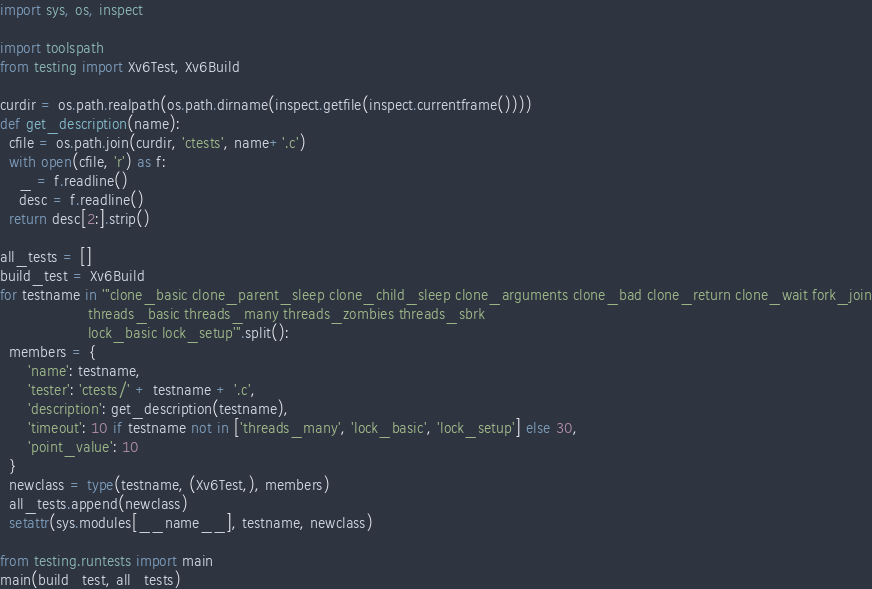Convert code to text. <code><loc_0><loc_0><loc_500><loc_500><_Python_>import sys, os, inspect

import toolspath
from testing import Xv6Test, Xv6Build

curdir = os.path.realpath(os.path.dirname(inspect.getfile(inspect.currentframe())))
def get_description(name):
  cfile = os.path.join(curdir, 'ctests', name+'.c')
  with open(cfile, 'r') as f:
    _ = f.readline()
    desc = f.readline()
  return desc[2:].strip()

all_tests = []
build_test = Xv6Build
for testname in '''clone_basic clone_parent_sleep clone_child_sleep clone_arguments clone_bad clone_return clone_wait fork_join
                   threads_basic threads_many threads_zombies threads_sbrk
                   lock_basic lock_setup'''.split():
  members = {
      'name': testname,
      'tester': 'ctests/' + testname + '.c',
      'description': get_description(testname),
      'timeout': 10 if testname not in ['threads_many', 'lock_basic', 'lock_setup'] else 30,
      'point_value': 10
  }
  newclass = type(testname, (Xv6Test,), members)
  all_tests.append(newclass)
  setattr(sys.modules[__name__], testname, newclass)

from testing.runtests import main
main(build_test, all_tests)
</code> 